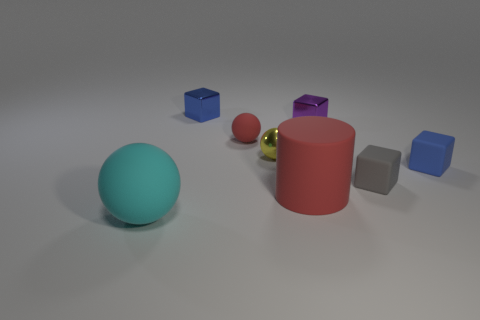There is a shiny cube that is the same size as the purple metallic thing; what is its color?
Your response must be concise. Blue. What number of blue objects are big rubber cylinders or small matte blocks?
Provide a succinct answer. 1. Is the number of rubber objects greater than the number of small things?
Offer a very short reply. No. Is the size of the cube on the right side of the gray cube the same as the blue block that is to the left of the yellow sphere?
Ensure brevity in your answer.  Yes. There is a tiny thing that is in front of the tiny blue cube on the right side of the large object to the right of the cyan rubber ball; what is its color?
Your response must be concise. Gray. Is there a small yellow metallic object of the same shape as the cyan object?
Give a very brief answer. Yes. Is the number of rubber blocks in front of the tiny blue matte block greater than the number of big yellow blocks?
Offer a terse response. Yes. What number of matte things are either large red things or big cyan balls?
Ensure brevity in your answer.  2. There is a object that is on the left side of the small red ball and in front of the small purple shiny object; what size is it?
Your response must be concise. Large. Is there a tiny yellow shiny ball that is on the right side of the big cyan object in front of the small rubber ball?
Keep it short and to the point. Yes. 